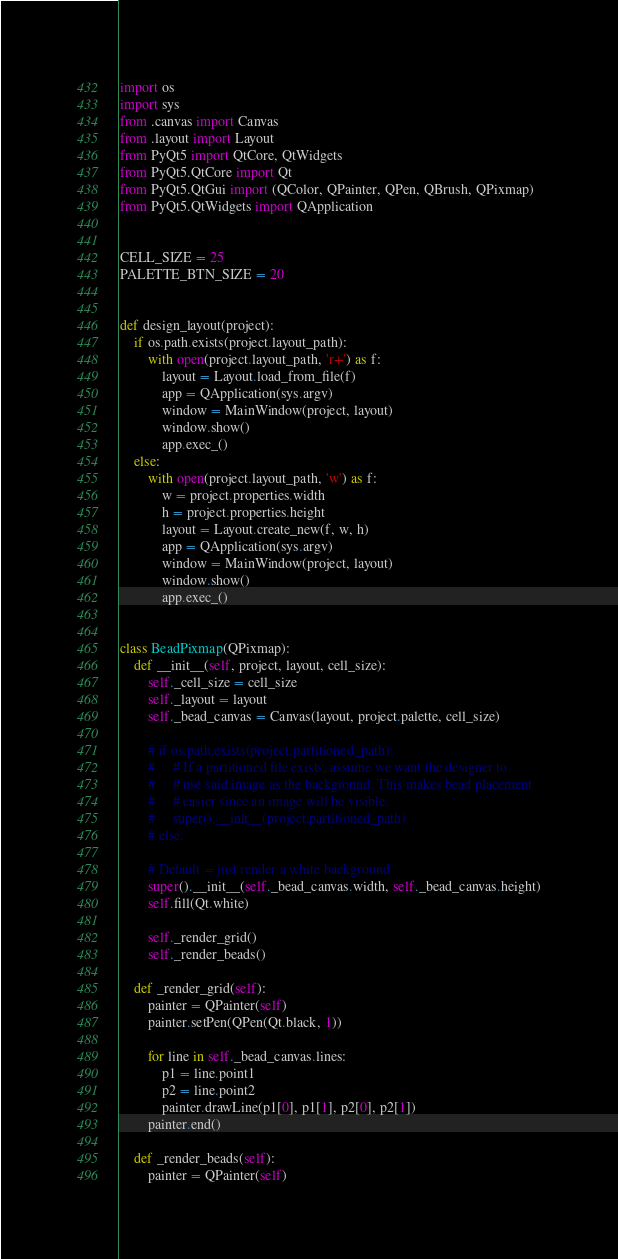Convert code to text. <code><loc_0><loc_0><loc_500><loc_500><_Python_>import os
import sys
from .canvas import Canvas
from .layout import Layout
from PyQt5 import QtCore, QtWidgets
from PyQt5.QtCore import Qt
from PyQt5.QtGui import (QColor, QPainter, QPen, QBrush, QPixmap)
from PyQt5.QtWidgets import QApplication


CELL_SIZE = 25
PALETTE_BTN_SIZE = 20


def design_layout(project):
    if os.path.exists(project.layout_path):
        with open(project.layout_path, 'r+') as f:
            layout = Layout.load_from_file(f)
            app = QApplication(sys.argv)
            window = MainWindow(project, layout)
            window.show()
            app.exec_()
    else:
        with open(project.layout_path, 'w') as f:
            w = project.properties.width
            h = project.properties.height
            layout = Layout.create_new(f, w, h)
            app = QApplication(sys.argv)
            window = MainWindow(project, layout)
            window.show()
            app.exec_()


class BeadPixmap(QPixmap):
    def __init__(self, project, layout, cell_size):
        self._cell_size = cell_size
        self._layout = layout
        self._bead_canvas = Canvas(layout, project.palette, cell_size)

        # if os.path.exists(project.partitioned_path):
        #     # If a partitioned file exists, assume we want the designer to
        #     # use said image as the background. This makes bead placement
        #     # easier since an image will be visible.
        #     super().__init__(project.partitioned_path)
        # else:

        # Default = just render a white background
        super().__init__(self._bead_canvas.width, self._bead_canvas.height)
        self.fill(Qt.white)

        self._render_grid()
        self._render_beads()

    def _render_grid(self):
        painter = QPainter(self)
        painter.setPen(QPen(Qt.black, 1))

        for line in self._bead_canvas.lines:
            p1 = line.point1
            p2 = line.point2
            painter.drawLine(p1[0], p1[1], p2[0], p2[1])
        painter.end()

    def _render_beads(self):
        painter = QPainter(self)</code> 